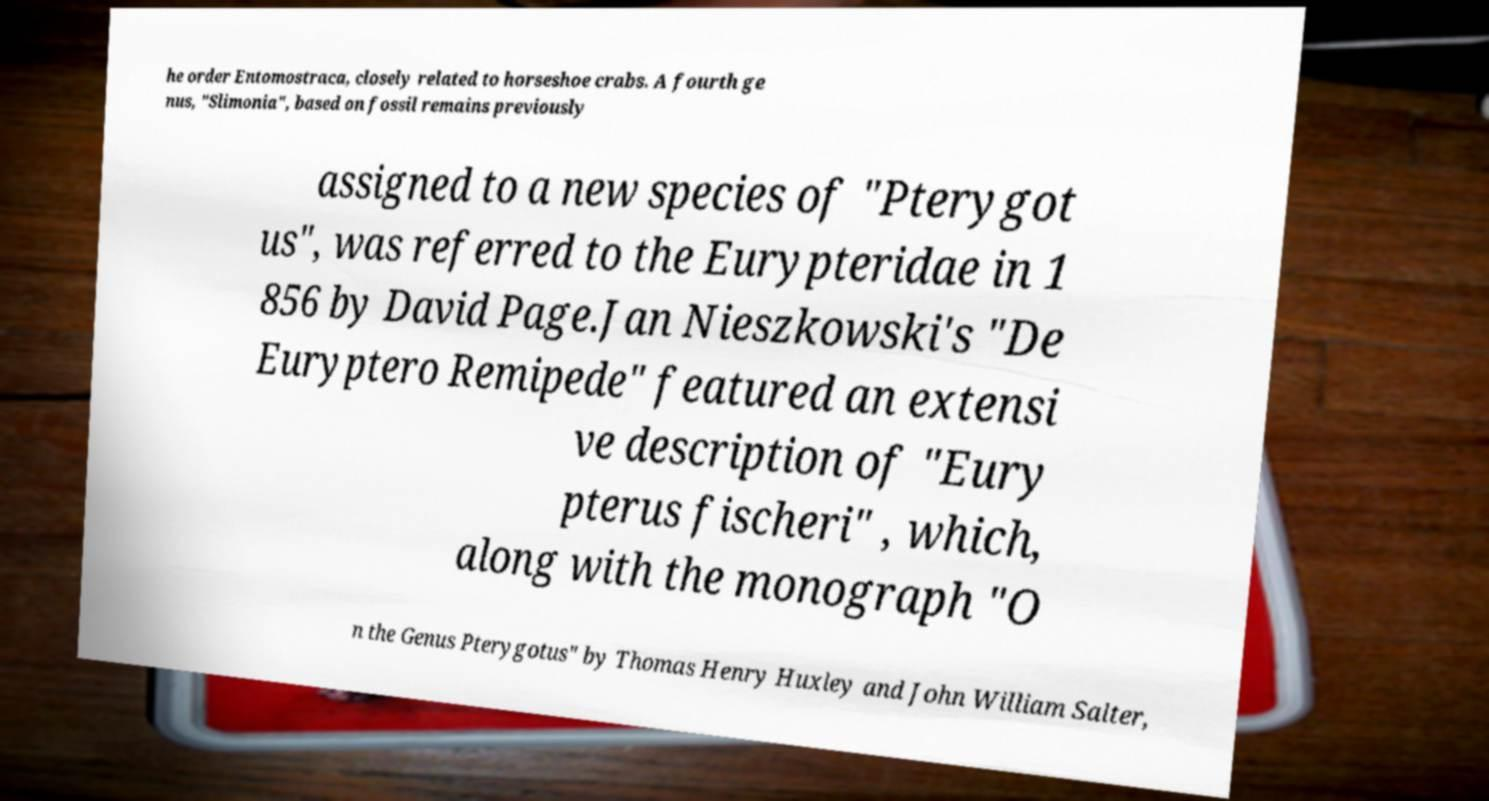Can you accurately transcribe the text from the provided image for me? he order Entomostraca, closely related to horseshoe crabs. A fourth ge nus, "Slimonia", based on fossil remains previously assigned to a new species of "Pterygot us", was referred to the Eurypteridae in 1 856 by David Page.Jan Nieszkowski's "De Euryptero Remipede" featured an extensi ve description of "Eury pterus fischeri" , which, along with the monograph "O n the Genus Pterygotus" by Thomas Henry Huxley and John William Salter, 